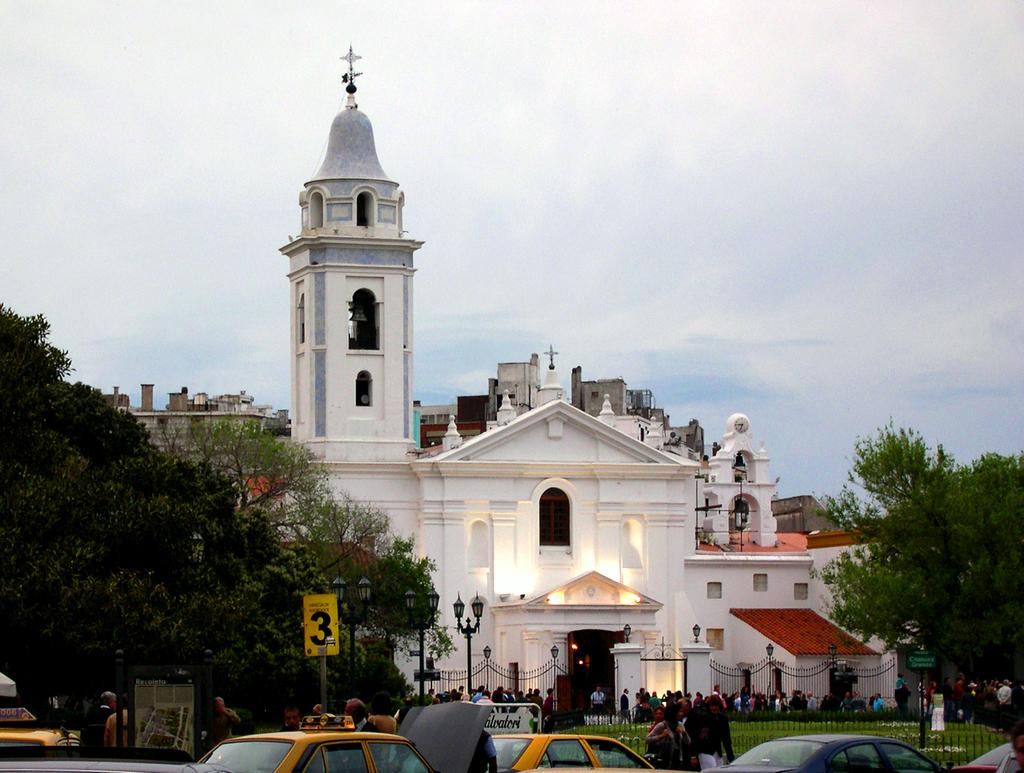What types of objects can be seen in the image? There are vehicles and persons in the image. Can you describe the setting in the image? There is a building in the background of the image, with trees on either side of it. What might the persons in the image be doing? It is not clear from the image what the persons are doing, but they may be interacting with the vehicles. What type of bead is being used to create the pattern on the bag in the image? There is no bag or pattern present in the image, so it is not possible to answer that question. 